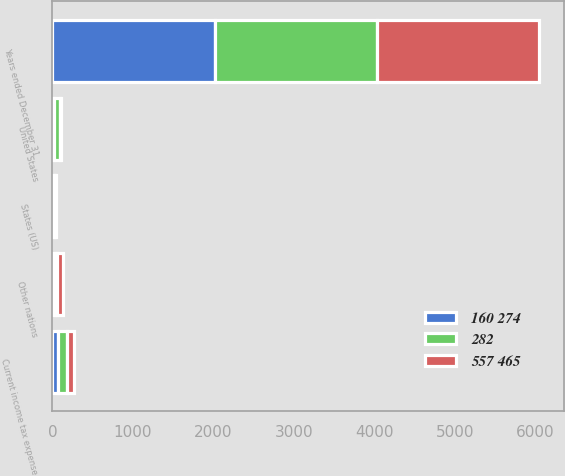Convert chart. <chart><loc_0><loc_0><loc_500><loc_500><stacked_bar_chart><ecel><fcel>Years ended December 31<fcel>United States<fcel>Other nations<fcel>States (US)<fcel>Current income tax expense<nl><fcel>160 274<fcel>2016<fcel>20<fcel>31<fcel>18<fcel>69<nl><fcel>282<fcel>2015<fcel>71<fcel>30<fcel>13<fcel>114<nl><fcel>557 465<fcel>2014<fcel>14<fcel>67<fcel>11<fcel>92<nl></chart> 